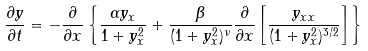<formula> <loc_0><loc_0><loc_500><loc_500>\frac { \partial y } { \partial t } = - \frac { \partial } { \partial x } \left \{ \frac { \alpha y _ { x } } { 1 + y _ { x } ^ { 2 } } + \frac { \beta } { ( 1 + y _ { x } ^ { 2 } ) ^ { \nu } } \frac { \partial } { \partial x } \left [ \frac { y _ { x x } } { ( 1 + y _ { x } ^ { 2 } ) ^ { 3 / 2 } } \right ] \right \}</formula> 